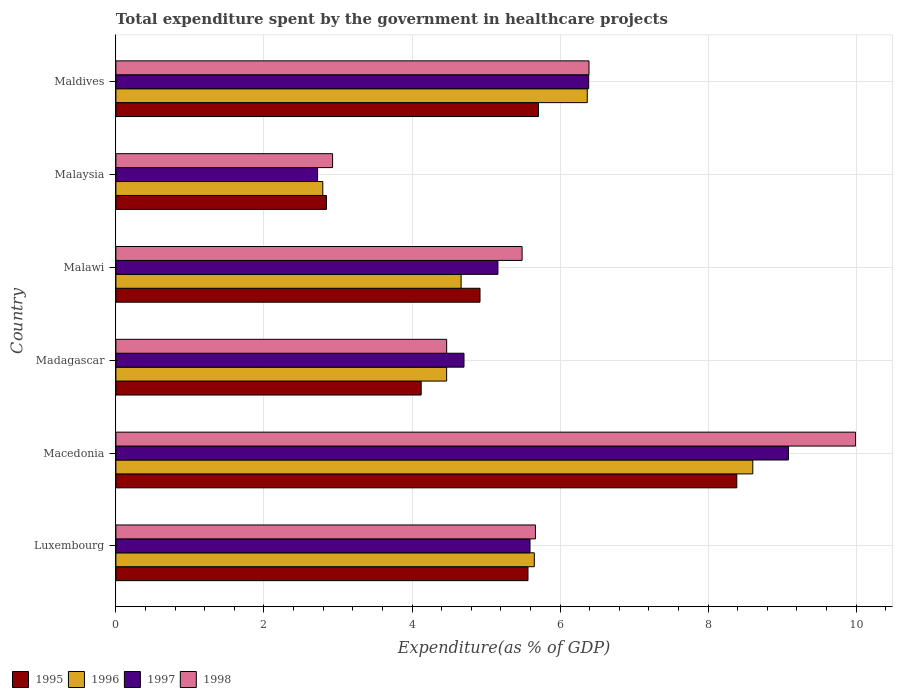Are the number of bars on each tick of the Y-axis equal?
Offer a very short reply. Yes. How many bars are there on the 3rd tick from the top?
Provide a succinct answer. 4. What is the label of the 2nd group of bars from the top?
Give a very brief answer. Malaysia. What is the total expenditure spent by the government in healthcare projects in 1998 in Malaysia?
Your answer should be very brief. 2.93. Across all countries, what is the maximum total expenditure spent by the government in healthcare projects in 1997?
Your answer should be compact. 9.09. Across all countries, what is the minimum total expenditure spent by the government in healthcare projects in 1998?
Keep it short and to the point. 2.93. In which country was the total expenditure spent by the government in healthcare projects in 1998 maximum?
Make the answer very short. Macedonia. In which country was the total expenditure spent by the government in healthcare projects in 1996 minimum?
Keep it short and to the point. Malaysia. What is the total total expenditure spent by the government in healthcare projects in 1997 in the graph?
Make the answer very short. 33.65. What is the difference between the total expenditure spent by the government in healthcare projects in 1996 in Luxembourg and that in Madagascar?
Your answer should be very brief. 1.18. What is the difference between the total expenditure spent by the government in healthcare projects in 1996 in Luxembourg and the total expenditure spent by the government in healthcare projects in 1997 in Macedonia?
Provide a succinct answer. -3.43. What is the average total expenditure spent by the government in healthcare projects in 1996 per country?
Offer a terse response. 5.43. What is the difference between the total expenditure spent by the government in healthcare projects in 1995 and total expenditure spent by the government in healthcare projects in 1997 in Madagascar?
Make the answer very short. -0.58. What is the ratio of the total expenditure spent by the government in healthcare projects in 1998 in Macedonia to that in Madagascar?
Your answer should be compact. 2.24. Is the difference between the total expenditure spent by the government in healthcare projects in 1995 in Macedonia and Malawi greater than the difference between the total expenditure spent by the government in healthcare projects in 1997 in Macedonia and Malawi?
Keep it short and to the point. No. What is the difference between the highest and the second highest total expenditure spent by the government in healthcare projects in 1997?
Provide a succinct answer. 2.7. What is the difference between the highest and the lowest total expenditure spent by the government in healthcare projects in 1996?
Your answer should be compact. 5.81. What does the 1st bar from the top in Maldives represents?
Provide a short and direct response. 1998. What does the 3rd bar from the bottom in Madagascar represents?
Keep it short and to the point. 1997. Are all the bars in the graph horizontal?
Provide a short and direct response. Yes. Are the values on the major ticks of X-axis written in scientific E-notation?
Ensure brevity in your answer.  No. How many legend labels are there?
Give a very brief answer. 4. How are the legend labels stacked?
Keep it short and to the point. Horizontal. What is the title of the graph?
Keep it short and to the point. Total expenditure spent by the government in healthcare projects. Does "1969" appear as one of the legend labels in the graph?
Ensure brevity in your answer.  No. What is the label or title of the X-axis?
Offer a very short reply. Expenditure(as % of GDP). What is the Expenditure(as % of GDP) in 1995 in Luxembourg?
Ensure brevity in your answer.  5.57. What is the Expenditure(as % of GDP) of 1996 in Luxembourg?
Ensure brevity in your answer.  5.65. What is the Expenditure(as % of GDP) of 1997 in Luxembourg?
Ensure brevity in your answer.  5.59. What is the Expenditure(as % of GDP) in 1998 in Luxembourg?
Provide a succinct answer. 5.67. What is the Expenditure(as % of GDP) in 1995 in Macedonia?
Your response must be concise. 8.39. What is the Expenditure(as % of GDP) in 1996 in Macedonia?
Make the answer very short. 8.6. What is the Expenditure(as % of GDP) in 1997 in Macedonia?
Provide a short and direct response. 9.09. What is the Expenditure(as % of GDP) of 1998 in Macedonia?
Your answer should be compact. 9.99. What is the Expenditure(as % of GDP) of 1995 in Madagascar?
Your answer should be compact. 4.12. What is the Expenditure(as % of GDP) of 1996 in Madagascar?
Your response must be concise. 4.47. What is the Expenditure(as % of GDP) of 1997 in Madagascar?
Give a very brief answer. 4.7. What is the Expenditure(as % of GDP) of 1998 in Madagascar?
Make the answer very short. 4.47. What is the Expenditure(as % of GDP) in 1995 in Malawi?
Ensure brevity in your answer.  4.92. What is the Expenditure(as % of GDP) of 1996 in Malawi?
Your answer should be compact. 4.66. What is the Expenditure(as % of GDP) in 1997 in Malawi?
Offer a terse response. 5.16. What is the Expenditure(as % of GDP) of 1998 in Malawi?
Your response must be concise. 5.49. What is the Expenditure(as % of GDP) in 1995 in Malaysia?
Your answer should be compact. 2.84. What is the Expenditure(as % of GDP) in 1996 in Malaysia?
Your response must be concise. 2.8. What is the Expenditure(as % of GDP) of 1997 in Malaysia?
Give a very brief answer. 2.72. What is the Expenditure(as % of GDP) in 1998 in Malaysia?
Provide a succinct answer. 2.93. What is the Expenditure(as % of GDP) of 1995 in Maldives?
Your answer should be compact. 5.71. What is the Expenditure(as % of GDP) in 1996 in Maldives?
Offer a terse response. 6.37. What is the Expenditure(as % of GDP) of 1997 in Maldives?
Provide a short and direct response. 6.39. What is the Expenditure(as % of GDP) of 1998 in Maldives?
Give a very brief answer. 6.39. Across all countries, what is the maximum Expenditure(as % of GDP) of 1995?
Offer a very short reply. 8.39. Across all countries, what is the maximum Expenditure(as % of GDP) in 1996?
Your response must be concise. 8.6. Across all countries, what is the maximum Expenditure(as % of GDP) in 1997?
Ensure brevity in your answer.  9.09. Across all countries, what is the maximum Expenditure(as % of GDP) of 1998?
Keep it short and to the point. 9.99. Across all countries, what is the minimum Expenditure(as % of GDP) in 1995?
Make the answer very short. 2.84. Across all countries, what is the minimum Expenditure(as % of GDP) in 1996?
Provide a short and direct response. 2.8. Across all countries, what is the minimum Expenditure(as % of GDP) of 1997?
Your answer should be compact. 2.72. Across all countries, what is the minimum Expenditure(as % of GDP) of 1998?
Ensure brevity in your answer.  2.93. What is the total Expenditure(as % of GDP) in 1995 in the graph?
Make the answer very short. 31.55. What is the total Expenditure(as % of GDP) of 1996 in the graph?
Provide a short and direct response. 32.55. What is the total Expenditure(as % of GDP) in 1997 in the graph?
Provide a succinct answer. 33.65. What is the total Expenditure(as % of GDP) in 1998 in the graph?
Your response must be concise. 34.93. What is the difference between the Expenditure(as % of GDP) of 1995 in Luxembourg and that in Macedonia?
Your answer should be compact. -2.82. What is the difference between the Expenditure(as % of GDP) of 1996 in Luxembourg and that in Macedonia?
Give a very brief answer. -2.95. What is the difference between the Expenditure(as % of GDP) of 1997 in Luxembourg and that in Macedonia?
Your answer should be very brief. -3.49. What is the difference between the Expenditure(as % of GDP) in 1998 in Luxembourg and that in Macedonia?
Keep it short and to the point. -4.32. What is the difference between the Expenditure(as % of GDP) in 1995 in Luxembourg and that in Madagascar?
Make the answer very short. 1.44. What is the difference between the Expenditure(as % of GDP) in 1996 in Luxembourg and that in Madagascar?
Offer a very short reply. 1.18. What is the difference between the Expenditure(as % of GDP) of 1997 in Luxembourg and that in Madagascar?
Offer a very short reply. 0.89. What is the difference between the Expenditure(as % of GDP) of 1998 in Luxembourg and that in Madagascar?
Give a very brief answer. 1.2. What is the difference between the Expenditure(as % of GDP) in 1995 in Luxembourg and that in Malawi?
Your response must be concise. 0.65. What is the difference between the Expenditure(as % of GDP) in 1996 in Luxembourg and that in Malawi?
Provide a short and direct response. 0.99. What is the difference between the Expenditure(as % of GDP) in 1997 in Luxembourg and that in Malawi?
Your answer should be compact. 0.43. What is the difference between the Expenditure(as % of GDP) of 1998 in Luxembourg and that in Malawi?
Provide a short and direct response. 0.18. What is the difference between the Expenditure(as % of GDP) in 1995 in Luxembourg and that in Malaysia?
Give a very brief answer. 2.72. What is the difference between the Expenditure(as % of GDP) in 1996 in Luxembourg and that in Malaysia?
Provide a succinct answer. 2.86. What is the difference between the Expenditure(as % of GDP) of 1997 in Luxembourg and that in Malaysia?
Your answer should be compact. 2.87. What is the difference between the Expenditure(as % of GDP) of 1998 in Luxembourg and that in Malaysia?
Offer a terse response. 2.74. What is the difference between the Expenditure(as % of GDP) in 1995 in Luxembourg and that in Maldives?
Your answer should be compact. -0.14. What is the difference between the Expenditure(as % of GDP) of 1996 in Luxembourg and that in Maldives?
Make the answer very short. -0.72. What is the difference between the Expenditure(as % of GDP) in 1997 in Luxembourg and that in Maldives?
Offer a terse response. -0.79. What is the difference between the Expenditure(as % of GDP) in 1998 in Luxembourg and that in Maldives?
Offer a terse response. -0.72. What is the difference between the Expenditure(as % of GDP) of 1995 in Macedonia and that in Madagascar?
Offer a very short reply. 4.26. What is the difference between the Expenditure(as % of GDP) of 1996 in Macedonia and that in Madagascar?
Offer a terse response. 4.14. What is the difference between the Expenditure(as % of GDP) of 1997 in Macedonia and that in Madagascar?
Your answer should be compact. 4.38. What is the difference between the Expenditure(as % of GDP) of 1998 in Macedonia and that in Madagascar?
Your response must be concise. 5.52. What is the difference between the Expenditure(as % of GDP) in 1995 in Macedonia and that in Malawi?
Make the answer very short. 3.47. What is the difference between the Expenditure(as % of GDP) of 1996 in Macedonia and that in Malawi?
Your response must be concise. 3.94. What is the difference between the Expenditure(as % of GDP) of 1997 in Macedonia and that in Malawi?
Provide a succinct answer. 3.92. What is the difference between the Expenditure(as % of GDP) of 1998 in Macedonia and that in Malawi?
Ensure brevity in your answer.  4.5. What is the difference between the Expenditure(as % of GDP) in 1995 in Macedonia and that in Malaysia?
Give a very brief answer. 5.54. What is the difference between the Expenditure(as % of GDP) in 1996 in Macedonia and that in Malaysia?
Provide a short and direct response. 5.81. What is the difference between the Expenditure(as % of GDP) of 1997 in Macedonia and that in Malaysia?
Your answer should be compact. 6.36. What is the difference between the Expenditure(as % of GDP) of 1998 in Macedonia and that in Malaysia?
Make the answer very short. 7.06. What is the difference between the Expenditure(as % of GDP) in 1995 in Macedonia and that in Maldives?
Offer a terse response. 2.68. What is the difference between the Expenditure(as % of GDP) in 1996 in Macedonia and that in Maldives?
Your answer should be compact. 2.24. What is the difference between the Expenditure(as % of GDP) in 1997 in Macedonia and that in Maldives?
Offer a terse response. 2.7. What is the difference between the Expenditure(as % of GDP) in 1998 in Macedonia and that in Maldives?
Keep it short and to the point. 3.6. What is the difference between the Expenditure(as % of GDP) of 1995 in Madagascar and that in Malawi?
Offer a terse response. -0.79. What is the difference between the Expenditure(as % of GDP) in 1996 in Madagascar and that in Malawi?
Provide a succinct answer. -0.2. What is the difference between the Expenditure(as % of GDP) of 1997 in Madagascar and that in Malawi?
Keep it short and to the point. -0.46. What is the difference between the Expenditure(as % of GDP) in 1998 in Madagascar and that in Malawi?
Offer a terse response. -1.02. What is the difference between the Expenditure(as % of GDP) in 1995 in Madagascar and that in Malaysia?
Provide a short and direct response. 1.28. What is the difference between the Expenditure(as % of GDP) in 1996 in Madagascar and that in Malaysia?
Ensure brevity in your answer.  1.67. What is the difference between the Expenditure(as % of GDP) of 1997 in Madagascar and that in Malaysia?
Offer a terse response. 1.98. What is the difference between the Expenditure(as % of GDP) in 1998 in Madagascar and that in Malaysia?
Offer a very short reply. 1.54. What is the difference between the Expenditure(as % of GDP) in 1995 in Madagascar and that in Maldives?
Make the answer very short. -1.58. What is the difference between the Expenditure(as % of GDP) in 1996 in Madagascar and that in Maldives?
Ensure brevity in your answer.  -1.9. What is the difference between the Expenditure(as % of GDP) in 1997 in Madagascar and that in Maldives?
Your answer should be compact. -1.68. What is the difference between the Expenditure(as % of GDP) in 1998 in Madagascar and that in Maldives?
Your response must be concise. -1.92. What is the difference between the Expenditure(as % of GDP) of 1995 in Malawi and that in Malaysia?
Keep it short and to the point. 2.07. What is the difference between the Expenditure(as % of GDP) of 1996 in Malawi and that in Malaysia?
Keep it short and to the point. 1.87. What is the difference between the Expenditure(as % of GDP) of 1997 in Malawi and that in Malaysia?
Provide a short and direct response. 2.44. What is the difference between the Expenditure(as % of GDP) of 1998 in Malawi and that in Malaysia?
Offer a very short reply. 2.56. What is the difference between the Expenditure(as % of GDP) of 1995 in Malawi and that in Maldives?
Your response must be concise. -0.79. What is the difference between the Expenditure(as % of GDP) in 1996 in Malawi and that in Maldives?
Keep it short and to the point. -1.7. What is the difference between the Expenditure(as % of GDP) in 1997 in Malawi and that in Maldives?
Offer a very short reply. -1.23. What is the difference between the Expenditure(as % of GDP) in 1998 in Malawi and that in Maldives?
Ensure brevity in your answer.  -0.9. What is the difference between the Expenditure(as % of GDP) of 1995 in Malaysia and that in Maldives?
Your answer should be very brief. -2.86. What is the difference between the Expenditure(as % of GDP) of 1996 in Malaysia and that in Maldives?
Offer a very short reply. -3.57. What is the difference between the Expenditure(as % of GDP) of 1997 in Malaysia and that in Maldives?
Keep it short and to the point. -3.66. What is the difference between the Expenditure(as % of GDP) in 1998 in Malaysia and that in Maldives?
Provide a short and direct response. -3.46. What is the difference between the Expenditure(as % of GDP) in 1995 in Luxembourg and the Expenditure(as % of GDP) in 1996 in Macedonia?
Your response must be concise. -3.04. What is the difference between the Expenditure(as % of GDP) in 1995 in Luxembourg and the Expenditure(as % of GDP) in 1997 in Macedonia?
Ensure brevity in your answer.  -3.52. What is the difference between the Expenditure(as % of GDP) of 1995 in Luxembourg and the Expenditure(as % of GDP) of 1998 in Macedonia?
Your response must be concise. -4.42. What is the difference between the Expenditure(as % of GDP) of 1996 in Luxembourg and the Expenditure(as % of GDP) of 1997 in Macedonia?
Provide a succinct answer. -3.43. What is the difference between the Expenditure(as % of GDP) of 1996 in Luxembourg and the Expenditure(as % of GDP) of 1998 in Macedonia?
Your answer should be compact. -4.34. What is the difference between the Expenditure(as % of GDP) in 1997 in Luxembourg and the Expenditure(as % of GDP) in 1998 in Macedonia?
Provide a succinct answer. -4.4. What is the difference between the Expenditure(as % of GDP) of 1995 in Luxembourg and the Expenditure(as % of GDP) of 1996 in Madagascar?
Ensure brevity in your answer.  1.1. What is the difference between the Expenditure(as % of GDP) of 1995 in Luxembourg and the Expenditure(as % of GDP) of 1997 in Madagascar?
Your response must be concise. 0.86. What is the difference between the Expenditure(as % of GDP) of 1995 in Luxembourg and the Expenditure(as % of GDP) of 1998 in Madagascar?
Give a very brief answer. 1.1. What is the difference between the Expenditure(as % of GDP) in 1996 in Luxembourg and the Expenditure(as % of GDP) in 1997 in Madagascar?
Keep it short and to the point. 0.95. What is the difference between the Expenditure(as % of GDP) of 1996 in Luxembourg and the Expenditure(as % of GDP) of 1998 in Madagascar?
Your answer should be compact. 1.18. What is the difference between the Expenditure(as % of GDP) of 1997 in Luxembourg and the Expenditure(as % of GDP) of 1998 in Madagascar?
Make the answer very short. 1.13. What is the difference between the Expenditure(as % of GDP) in 1995 in Luxembourg and the Expenditure(as % of GDP) in 1996 in Malawi?
Provide a succinct answer. 0.9. What is the difference between the Expenditure(as % of GDP) of 1995 in Luxembourg and the Expenditure(as % of GDP) of 1997 in Malawi?
Ensure brevity in your answer.  0.41. What is the difference between the Expenditure(as % of GDP) of 1995 in Luxembourg and the Expenditure(as % of GDP) of 1998 in Malawi?
Give a very brief answer. 0.08. What is the difference between the Expenditure(as % of GDP) of 1996 in Luxembourg and the Expenditure(as % of GDP) of 1997 in Malawi?
Ensure brevity in your answer.  0.49. What is the difference between the Expenditure(as % of GDP) of 1996 in Luxembourg and the Expenditure(as % of GDP) of 1998 in Malawi?
Give a very brief answer. 0.17. What is the difference between the Expenditure(as % of GDP) in 1997 in Luxembourg and the Expenditure(as % of GDP) in 1998 in Malawi?
Offer a terse response. 0.11. What is the difference between the Expenditure(as % of GDP) of 1995 in Luxembourg and the Expenditure(as % of GDP) of 1996 in Malaysia?
Provide a short and direct response. 2.77. What is the difference between the Expenditure(as % of GDP) in 1995 in Luxembourg and the Expenditure(as % of GDP) in 1997 in Malaysia?
Provide a short and direct response. 2.84. What is the difference between the Expenditure(as % of GDP) in 1995 in Luxembourg and the Expenditure(as % of GDP) in 1998 in Malaysia?
Provide a short and direct response. 2.64. What is the difference between the Expenditure(as % of GDP) of 1996 in Luxembourg and the Expenditure(as % of GDP) of 1997 in Malaysia?
Give a very brief answer. 2.93. What is the difference between the Expenditure(as % of GDP) of 1996 in Luxembourg and the Expenditure(as % of GDP) of 1998 in Malaysia?
Offer a very short reply. 2.73. What is the difference between the Expenditure(as % of GDP) in 1997 in Luxembourg and the Expenditure(as % of GDP) in 1998 in Malaysia?
Your answer should be very brief. 2.67. What is the difference between the Expenditure(as % of GDP) of 1995 in Luxembourg and the Expenditure(as % of GDP) of 1996 in Maldives?
Give a very brief answer. -0.8. What is the difference between the Expenditure(as % of GDP) of 1995 in Luxembourg and the Expenditure(as % of GDP) of 1997 in Maldives?
Your response must be concise. -0.82. What is the difference between the Expenditure(as % of GDP) in 1995 in Luxembourg and the Expenditure(as % of GDP) in 1998 in Maldives?
Provide a short and direct response. -0.82. What is the difference between the Expenditure(as % of GDP) of 1996 in Luxembourg and the Expenditure(as % of GDP) of 1997 in Maldives?
Ensure brevity in your answer.  -0.73. What is the difference between the Expenditure(as % of GDP) in 1996 in Luxembourg and the Expenditure(as % of GDP) in 1998 in Maldives?
Ensure brevity in your answer.  -0.74. What is the difference between the Expenditure(as % of GDP) in 1997 in Luxembourg and the Expenditure(as % of GDP) in 1998 in Maldives?
Provide a succinct answer. -0.8. What is the difference between the Expenditure(as % of GDP) of 1995 in Macedonia and the Expenditure(as % of GDP) of 1996 in Madagascar?
Your response must be concise. 3.92. What is the difference between the Expenditure(as % of GDP) in 1995 in Macedonia and the Expenditure(as % of GDP) in 1997 in Madagascar?
Your response must be concise. 3.69. What is the difference between the Expenditure(as % of GDP) of 1995 in Macedonia and the Expenditure(as % of GDP) of 1998 in Madagascar?
Provide a succinct answer. 3.92. What is the difference between the Expenditure(as % of GDP) of 1996 in Macedonia and the Expenditure(as % of GDP) of 1997 in Madagascar?
Make the answer very short. 3.9. What is the difference between the Expenditure(as % of GDP) of 1996 in Macedonia and the Expenditure(as % of GDP) of 1998 in Madagascar?
Your answer should be very brief. 4.14. What is the difference between the Expenditure(as % of GDP) of 1997 in Macedonia and the Expenditure(as % of GDP) of 1998 in Madagascar?
Give a very brief answer. 4.62. What is the difference between the Expenditure(as % of GDP) of 1995 in Macedonia and the Expenditure(as % of GDP) of 1996 in Malawi?
Offer a terse response. 3.72. What is the difference between the Expenditure(as % of GDP) in 1995 in Macedonia and the Expenditure(as % of GDP) in 1997 in Malawi?
Provide a short and direct response. 3.23. What is the difference between the Expenditure(as % of GDP) of 1995 in Macedonia and the Expenditure(as % of GDP) of 1998 in Malawi?
Provide a short and direct response. 2.9. What is the difference between the Expenditure(as % of GDP) of 1996 in Macedonia and the Expenditure(as % of GDP) of 1997 in Malawi?
Offer a very short reply. 3.44. What is the difference between the Expenditure(as % of GDP) of 1996 in Macedonia and the Expenditure(as % of GDP) of 1998 in Malawi?
Ensure brevity in your answer.  3.12. What is the difference between the Expenditure(as % of GDP) in 1997 in Macedonia and the Expenditure(as % of GDP) in 1998 in Malawi?
Keep it short and to the point. 3.6. What is the difference between the Expenditure(as % of GDP) in 1995 in Macedonia and the Expenditure(as % of GDP) in 1996 in Malaysia?
Your answer should be compact. 5.59. What is the difference between the Expenditure(as % of GDP) in 1995 in Macedonia and the Expenditure(as % of GDP) in 1997 in Malaysia?
Make the answer very short. 5.66. What is the difference between the Expenditure(as % of GDP) of 1995 in Macedonia and the Expenditure(as % of GDP) of 1998 in Malaysia?
Provide a short and direct response. 5.46. What is the difference between the Expenditure(as % of GDP) in 1996 in Macedonia and the Expenditure(as % of GDP) in 1997 in Malaysia?
Your response must be concise. 5.88. What is the difference between the Expenditure(as % of GDP) of 1996 in Macedonia and the Expenditure(as % of GDP) of 1998 in Malaysia?
Your answer should be very brief. 5.68. What is the difference between the Expenditure(as % of GDP) in 1997 in Macedonia and the Expenditure(as % of GDP) in 1998 in Malaysia?
Give a very brief answer. 6.16. What is the difference between the Expenditure(as % of GDP) in 1995 in Macedonia and the Expenditure(as % of GDP) in 1996 in Maldives?
Provide a succinct answer. 2.02. What is the difference between the Expenditure(as % of GDP) in 1995 in Macedonia and the Expenditure(as % of GDP) in 1997 in Maldives?
Give a very brief answer. 2. What is the difference between the Expenditure(as % of GDP) in 1995 in Macedonia and the Expenditure(as % of GDP) in 1998 in Maldives?
Your answer should be compact. 2. What is the difference between the Expenditure(as % of GDP) of 1996 in Macedonia and the Expenditure(as % of GDP) of 1997 in Maldives?
Your response must be concise. 2.22. What is the difference between the Expenditure(as % of GDP) of 1996 in Macedonia and the Expenditure(as % of GDP) of 1998 in Maldives?
Offer a very short reply. 2.21. What is the difference between the Expenditure(as % of GDP) of 1997 in Macedonia and the Expenditure(as % of GDP) of 1998 in Maldives?
Offer a terse response. 2.69. What is the difference between the Expenditure(as % of GDP) in 1995 in Madagascar and the Expenditure(as % of GDP) in 1996 in Malawi?
Ensure brevity in your answer.  -0.54. What is the difference between the Expenditure(as % of GDP) in 1995 in Madagascar and the Expenditure(as % of GDP) in 1997 in Malawi?
Ensure brevity in your answer.  -1.04. What is the difference between the Expenditure(as % of GDP) of 1995 in Madagascar and the Expenditure(as % of GDP) of 1998 in Malawi?
Give a very brief answer. -1.36. What is the difference between the Expenditure(as % of GDP) of 1996 in Madagascar and the Expenditure(as % of GDP) of 1997 in Malawi?
Give a very brief answer. -0.69. What is the difference between the Expenditure(as % of GDP) in 1996 in Madagascar and the Expenditure(as % of GDP) in 1998 in Malawi?
Provide a short and direct response. -1.02. What is the difference between the Expenditure(as % of GDP) in 1997 in Madagascar and the Expenditure(as % of GDP) in 1998 in Malawi?
Keep it short and to the point. -0.78. What is the difference between the Expenditure(as % of GDP) of 1995 in Madagascar and the Expenditure(as % of GDP) of 1996 in Malaysia?
Offer a very short reply. 1.33. What is the difference between the Expenditure(as % of GDP) of 1995 in Madagascar and the Expenditure(as % of GDP) of 1997 in Malaysia?
Ensure brevity in your answer.  1.4. What is the difference between the Expenditure(as % of GDP) in 1995 in Madagascar and the Expenditure(as % of GDP) in 1998 in Malaysia?
Give a very brief answer. 1.2. What is the difference between the Expenditure(as % of GDP) of 1996 in Madagascar and the Expenditure(as % of GDP) of 1997 in Malaysia?
Ensure brevity in your answer.  1.74. What is the difference between the Expenditure(as % of GDP) in 1996 in Madagascar and the Expenditure(as % of GDP) in 1998 in Malaysia?
Make the answer very short. 1.54. What is the difference between the Expenditure(as % of GDP) of 1997 in Madagascar and the Expenditure(as % of GDP) of 1998 in Malaysia?
Keep it short and to the point. 1.78. What is the difference between the Expenditure(as % of GDP) of 1995 in Madagascar and the Expenditure(as % of GDP) of 1996 in Maldives?
Your answer should be compact. -2.24. What is the difference between the Expenditure(as % of GDP) in 1995 in Madagascar and the Expenditure(as % of GDP) in 1997 in Maldives?
Give a very brief answer. -2.26. What is the difference between the Expenditure(as % of GDP) of 1995 in Madagascar and the Expenditure(as % of GDP) of 1998 in Maldives?
Provide a succinct answer. -2.27. What is the difference between the Expenditure(as % of GDP) of 1996 in Madagascar and the Expenditure(as % of GDP) of 1997 in Maldives?
Keep it short and to the point. -1.92. What is the difference between the Expenditure(as % of GDP) of 1996 in Madagascar and the Expenditure(as % of GDP) of 1998 in Maldives?
Your response must be concise. -1.92. What is the difference between the Expenditure(as % of GDP) in 1997 in Madagascar and the Expenditure(as % of GDP) in 1998 in Maldives?
Offer a terse response. -1.69. What is the difference between the Expenditure(as % of GDP) of 1995 in Malawi and the Expenditure(as % of GDP) of 1996 in Malaysia?
Your response must be concise. 2.12. What is the difference between the Expenditure(as % of GDP) in 1995 in Malawi and the Expenditure(as % of GDP) in 1997 in Malaysia?
Your answer should be very brief. 2.19. What is the difference between the Expenditure(as % of GDP) of 1995 in Malawi and the Expenditure(as % of GDP) of 1998 in Malaysia?
Give a very brief answer. 1.99. What is the difference between the Expenditure(as % of GDP) in 1996 in Malawi and the Expenditure(as % of GDP) in 1997 in Malaysia?
Give a very brief answer. 1.94. What is the difference between the Expenditure(as % of GDP) of 1996 in Malawi and the Expenditure(as % of GDP) of 1998 in Malaysia?
Offer a very short reply. 1.74. What is the difference between the Expenditure(as % of GDP) of 1997 in Malawi and the Expenditure(as % of GDP) of 1998 in Malaysia?
Offer a terse response. 2.23. What is the difference between the Expenditure(as % of GDP) of 1995 in Malawi and the Expenditure(as % of GDP) of 1996 in Maldives?
Keep it short and to the point. -1.45. What is the difference between the Expenditure(as % of GDP) of 1995 in Malawi and the Expenditure(as % of GDP) of 1997 in Maldives?
Offer a very short reply. -1.47. What is the difference between the Expenditure(as % of GDP) in 1995 in Malawi and the Expenditure(as % of GDP) in 1998 in Maldives?
Your response must be concise. -1.47. What is the difference between the Expenditure(as % of GDP) of 1996 in Malawi and the Expenditure(as % of GDP) of 1997 in Maldives?
Make the answer very short. -1.72. What is the difference between the Expenditure(as % of GDP) of 1996 in Malawi and the Expenditure(as % of GDP) of 1998 in Maldives?
Offer a very short reply. -1.73. What is the difference between the Expenditure(as % of GDP) of 1997 in Malawi and the Expenditure(as % of GDP) of 1998 in Maldives?
Ensure brevity in your answer.  -1.23. What is the difference between the Expenditure(as % of GDP) in 1995 in Malaysia and the Expenditure(as % of GDP) in 1996 in Maldives?
Offer a very short reply. -3.52. What is the difference between the Expenditure(as % of GDP) in 1995 in Malaysia and the Expenditure(as % of GDP) in 1997 in Maldives?
Your response must be concise. -3.54. What is the difference between the Expenditure(as % of GDP) of 1995 in Malaysia and the Expenditure(as % of GDP) of 1998 in Maldives?
Make the answer very short. -3.55. What is the difference between the Expenditure(as % of GDP) in 1996 in Malaysia and the Expenditure(as % of GDP) in 1997 in Maldives?
Offer a very short reply. -3.59. What is the difference between the Expenditure(as % of GDP) in 1996 in Malaysia and the Expenditure(as % of GDP) in 1998 in Maldives?
Keep it short and to the point. -3.6. What is the difference between the Expenditure(as % of GDP) of 1997 in Malaysia and the Expenditure(as % of GDP) of 1998 in Maldives?
Your answer should be very brief. -3.67. What is the average Expenditure(as % of GDP) in 1995 per country?
Give a very brief answer. 5.26. What is the average Expenditure(as % of GDP) in 1996 per country?
Provide a succinct answer. 5.42. What is the average Expenditure(as % of GDP) in 1997 per country?
Your answer should be very brief. 5.61. What is the average Expenditure(as % of GDP) in 1998 per country?
Provide a succinct answer. 5.82. What is the difference between the Expenditure(as % of GDP) in 1995 and Expenditure(as % of GDP) in 1996 in Luxembourg?
Provide a succinct answer. -0.09. What is the difference between the Expenditure(as % of GDP) in 1995 and Expenditure(as % of GDP) in 1997 in Luxembourg?
Keep it short and to the point. -0.03. What is the difference between the Expenditure(as % of GDP) of 1995 and Expenditure(as % of GDP) of 1998 in Luxembourg?
Offer a terse response. -0.1. What is the difference between the Expenditure(as % of GDP) in 1996 and Expenditure(as % of GDP) in 1997 in Luxembourg?
Offer a very short reply. 0.06. What is the difference between the Expenditure(as % of GDP) of 1996 and Expenditure(as % of GDP) of 1998 in Luxembourg?
Your answer should be compact. -0.02. What is the difference between the Expenditure(as % of GDP) in 1997 and Expenditure(as % of GDP) in 1998 in Luxembourg?
Give a very brief answer. -0.07. What is the difference between the Expenditure(as % of GDP) of 1995 and Expenditure(as % of GDP) of 1996 in Macedonia?
Keep it short and to the point. -0.22. What is the difference between the Expenditure(as % of GDP) of 1995 and Expenditure(as % of GDP) of 1997 in Macedonia?
Give a very brief answer. -0.7. What is the difference between the Expenditure(as % of GDP) in 1995 and Expenditure(as % of GDP) in 1998 in Macedonia?
Provide a succinct answer. -1.6. What is the difference between the Expenditure(as % of GDP) in 1996 and Expenditure(as % of GDP) in 1997 in Macedonia?
Your answer should be compact. -0.48. What is the difference between the Expenditure(as % of GDP) of 1996 and Expenditure(as % of GDP) of 1998 in Macedonia?
Your response must be concise. -1.39. What is the difference between the Expenditure(as % of GDP) in 1997 and Expenditure(as % of GDP) in 1998 in Macedonia?
Your response must be concise. -0.91. What is the difference between the Expenditure(as % of GDP) of 1995 and Expenditure(as % of GDP) of 1996 in Madagascar?
Your response must be concise. -0.34. What is the difference between the Expenditure(as % of GDP) of 1995 and Expenditure(as % of GDP) of 1997 in Madagascar?
Make the answer very short. -0.58. What is the difference between the Expenditure(as % of GDP) of 1995 and Expenditure(as % of GDP) of 1998 in Madagascar?
Make the answer very short. -0.34. What is the difference between the Expenditure(as % of GDP) of 1996 and Expenditure(as % of GDP) of 1997 in Madagascar?
Your response must be concise. -0.23. What is the difference between the Expenditure(as % of GDP) of 1996 and Expenditure(as % of GDP) of 1998 in Madagascar?
Provide a succinct answer. -0. What is the difference between the Expenditure(as % of GDP) in 1997 and Expenditure(as % of GDP) in 1998 in Madagascar?
Ensure brevity in your answer.  0.23. What is the difference between the Expenditure(as % of GDP) in 1995 and Expenditure(as % of GDP) in 1996 in Malawi?
Provide a short and direct response. 0.26. What is the difference between the Expenditure(as % of GDP) in 1995 and Expenditure(as % of GDP) in 1997 in Malawi?
Provide a short and direct response. -0.24. What is the difference between the Expenditure(as % of GDP) in 1995 and Expenditure(as % of GDP) in 1998 in Malawi?
Give a very brief answer. -0.57. What is the difference between the Expenditure(as % of GDP) in 1996 and Expenditure(as % of GDP) in 1997 in Malawi?
Provide a short and direct response. -0.5. What is the difference between the Expenditure(as % of GDP) in 1996 and Expenditure(as % of GDP) in 1998 in Malawi?
Offer a very short reply. -0.82. What is the difference between the Expenditure(as % of GDP) of 1997 and Expenditure(as % of GDP) of 1998 in Malawi?
Provide a short and direct response. -0.33. What is the difference between the Expenditure(as % of GDP) in 1995 and Expenditure(as % of GDP) in 1996 in Malaysia?
Your answer should be compact. 0.05. What is the difference between the Expenditure(as % of GDP) in 1995 and Expenditure(as % of GDP) in 1997 in Malaysia?
Make the answer very short. 0.12. What is the difference between the Expenditure(as % of GDP) in 1995 and Expenditure(as % of GDP) in 1998 in Malaysia?
Offer a very short reply. -0.08. What is the difference between the Expenditure(as % of GDP) of 1996 and Expenditure(as % of GDP) of 1997 in Malaysia?
Your answer should be compact. 0.07. What is the difference between the Expenditure(as % of GDP) in 1996 and Expenditure(as % of GDP) in 1998 in Malaysia?
Offer a very short reply. -0.13. What is the difference between the Expenditure(as % of GDP) of 1997 and Expenditure(as % of GDP) of 1998 in Malaysia?
Give a very brief answer. -0.2. What is the difference between the Expenditure(as % of GDP) of 1995 and Expenditure(as % of GDP) of 1996 in Maldives?
Your answer should be very brief. -0.66. What is the difference between the Expenditure(as % of GDP) of 1995 and Expenditure(as % of GDP) of 1997 in Maldives?
Make the answer very short. -0.68. What is the difference between the Expenditure(as % of GDP) in 1995 and Expenditure(as % of GDP) in 1998 in Maldives?
Keep it short and to the point. -0.68. What is the difference between the Expenditure(as % of GDP) of 1996 and Expenditure(as % of GDP) of 1997 in Maldives?
Your answer should be compact. -0.02. What is the difference between the Expenditure(as % of GDP) of 1996 and Expenditure(as % of GDP) of 1998 in Maldives?
Give a very brief answer. -0.02. What is the difference between the Expenditure(as % of GDP) in 1997 and Expenditure(as % of GDP) in 1998 in Maldives?
Offer a very short reply. -0. What is the ratio of the Expenditure(as % of GDP) in 1995 in Luxembourg to that in Macedonia?
Your response must be concise. 0.66. What is the ratio of the Expenditure(as % of GDP) of 1996 in Luxembourg to that in Macedonia?
Make the answer very short. 0.66. What is the ratio of the Expenditure(as % of GDP) in 1997 in Luxembourg to that in Macedonia?
Offer a very short reply. 0.62. What is the ratio of the Expenditure(as % of GDP) in 1998 in Luxembourg to that in Macedonia?
Provide a succinct answer. 0.57. What is the ratio of the Expenditure(as % of GDP) in 1995 in Luxembourg to that in Madagascar?
Make the answer very short. 1.35. What is the ratio of the Expenditure(as % of GDP) in 1996 in Luxembourg to that in Madagascar?
Your answer should be very brief. 1.26. What is the ratio of the Expenditure(as % of GDP) of 1997 in Luxembourg to that in Madagascar?
Provide a succinct answer. 1.19. What is the ratio of the Expenditure(as % of GDP) of 1998 in Luxembourg to that in Madagascar?
Offer a very short reply. 1.27. What is the ratio of the Expenditure(as % of GDP) of 1995 in Luxembourg to that in Malawi?
Your answer should be compact. 1.13. What is the ratio of the Expenditure(as % of GDP) of 1996 in Luxembourg to that in Malawi?
Your answer should be compact. 1.21. What is the ratio of the Expenditure(as % of GDP) of 1997 in Luxembourg to that in Malawi?
Offer a very short reply. 1.08. What is the ratio of the Expenditure(as % of GDP) in 1998 in Luxembourg to that in Malawi?
Provide a short and direct response. 1.03. What is the ratio of the Expenditure(as % of GDP) in 1995 in Luxembourg to that in Malaysia?
Give a very brief answer. 1.96. What is the ratio of the Expenditure(as % of GDP) of 1996 in Luxembourg to that in Malaysia?
Your response must be concise. 2.02. What is the ratio of the Expenditure(as % of GDP) of 1997 in Luxembourg to that in Malaysia?
Provide a succinct answer. 2.05. What is the ratio of the Expenditure(as % of GDP) of 1998 in Luxembourg to that in Malaysia?
Provide a short and direct response. 1.94. What is the ratio of the Expenditure(as % of GDP) in 1995 in Luxembourg to that in Maldives?
Your response must be concise. 0.98. What is the ratio of the Expenditure(as % of GDP) of 1996 in Luxembourg to that in Maldives?
Make the answer very short. 0.89. What is the ratio of the Expenditure(as % of GDP) of 1997 in Luxembourg to that in Maldives?
Your answer should be very brief. 0.88. What is the ratio of the Expenditure(as % of GDP) in 1998 in Luxembourg to that in Maldives?
Your answer should be very brief. 0.89. What is the ratio of the Expenditure(as % of GDP) of 1995 in Macedonia to that in Madagascar?
Offer a terse response. 2.03. What is the ratio of the Expenditure(as % of GDP) of 1996 in Macedonia to that in Madagascar?
Provide a succinct answer. 1.93. What is the ratio of the Expenditure(as % of GDP) of 1997 in Macedonia to that in Madagascar?
Keep it short and to the point. 1.93. What is the ratio of the Expenditure(as % of GDP) in 1998 in Macedonia to that in Madagascar?
Your response must be concise. 2.24. What is the ratio of the Expenditure(as % of GDP) of 1995 in Macedonia to that in Malawi?
Provide a succinct answer. 1.71. What is the ratio of the Expenditure(as % of GDP) in 1996 in Macedonia to that in Malawi?
Your answer should be compact. 1.84. What is the ratio of the Expenditure(as % of GDP) of 1997 in Macedonia to that in Malawi?
Provide a short and direct response. 1.76. What is the ratio of the Expenditure(as % of GDP) in 1998 in Macedonia to that in Malawi?
Your answer should be very brief. 1.82. What is the ratio of the Expenditure(as % of GDP) of 1995 in Macedonia to that in Malaysia?
Ensure brevity in your answer.  2.95. What is the ratio of the Expenditure(as % of GDP) of 1996 in Macedonia to that in Malaysia?
Offer a terse response. 3.08. What is the ratio of the Expenditure(as % of GDP) of 1997 in Macedonia to that in Malaysia?
Offer a very short reply. 3.33. What is the ratio of the Expenditure(as % of GDP) of 1998 in Macedonia to that in Malaysia?
Offer a terse response. 3.41. What is the ratio of the Expenditure(as % of GDP) in 1995 in Macedonia to that in Maldives?
Offer a very short reply. 1.47. What is the ratio of the Expenditure(as % of GDP) of 1996 in Macedonia to that in Maldives?
Provide a short and direct response. 1.35. What is the ratio of the Expenditure(as % of GDP) of 1997 in Macedonia to that in Maldives?
Give a very brief answer. 1.42. What is the ratio of the Expenditure(as % of GDP) of 1998 in Macedonia to that in Maldives?
Make the answer very short. 1.56. What is the ratio of the Expenditure(as % of GDP) in 1995 in Madagascar to that in Malawi?
Offer a terse response. 0.84. What is the ratio of the Expenditure(as % of GDP) in 1996 in Madagascar to that in Malawi?
Provide a short and direct response. 0.96. What is the ratio of the Expenditure(as % of GDP) of 1997 in Madagascar to that in Malawi?
Give a very brief answer. 0.91. What is the ratio of the Expenditure(as % of GDP) in 1998 in Madagascar to that in Malawi?
Offer a very short reply. 0.81. What is the ratio of the Expenditure(as % of GDP) of 1995 in Madagascar to that in Malaysia?
Provide a succinct answer. 1.45. What is the ratio of the Expenditure(as % of GDP) of 1996 in Madagascar to that in Malaysia?
Keep it short and to the point. 1.6. What is the ratio of the Expenditure(as % of GDP) of 1997 in Madagascar to that in Malaysia?
Keep it short and to the point. 1.73. What is the ratio of the Expenditure(as % of GDP) of 1998 in Madagascar to that in Malaysia?
Ensure brevity in your answer.  1.53. What is the ratio of the Expenditure(as % of GDP) in 1995 in Madagascar to that in Maldives?
Ensure brevity in your answer.  0.72. What is the ratio of the Expenditure(as % of GDP) of 1996 in Madagascar to that in Maldives?
Your answer should be very brief. 0.7. What is the ratio of the Expenditure(as % of GDP) of 1997 in Madagascar to that in Maldives?
Keep it short and to the point. 0.74. What is the ratio of the Expenditure(as % of GDP) of 1998 in Madagascar to that in Maldives?
Your answer should be very brief. 0.7. What is the ratio of the Expenditure(as % of GDP) of 1995 in Malawi to that in Malaysia?
Your answer should be very brief. 1.73. What is the ratio of the Expenditure(as % of GDP) of 1996 in Malawi to that in Malaysia?
Your response must be concise. 1.67. What is the ratio of the Expenditure(as % of GDP) of 1997 in Malawi to that in Malaysia?
Your answer should be compact. 1.89. What is the ratio of the Expenditure(as % of GDP) in 1998 in Malawi to that in Malaysia?
Give a very brief answer. 1.87. What is the ratio of the Expenditure(as % of GDP) in 1995 in Malawi to that in Maldives?
Your response must be concise. 0.86. What is the ratio of the Expenditure(as % of GDP) in 1996 in Malawi to that in Maldives?
Make the answer very short. 0.73. What is the ratio of the Expenditure(as % of GDP) in 1997 in Malawi to that in Maldives?
Offer a terse response. 0.81. What is the ratio of the Expenditure(as % of GDP) in 1998 in Malawi to that in Maldives?
Your answer should be compact. 0.86. What is the ratio of the Expenditure(as % of GDP) in 1995 in Malaysia to that in Maldives?
Provide a short and direct response. 0.5. What is the ratio of the Expenditure(as % of GDP) in 1996 in Malaysia to that in Maldives?
Your response must be concise. 0.44. What is the ratio of the Expenditure(as % of GDP) in 1997 in Malaysia to that in Maldives?
Provide a succinct answer. 0.43. What is the ratio of the Expenditure(as % of GDP) of 1998 in Malaysia to that in Maldives?
Your answer should be compact. 0.46. What is the difference between the highest and the second highest Expenditure(as % of GDP) of 1995?
Keep it short and to the point. 2.68. What is the difference between the highest and the second highest Expenditure(as % of GDP) of 1996?
Ensure brevity in your answer.  2.24. What is the difference between the highest and the second highest Expenditure(as % of GDP) of 1997?
Keep it short and to the point. 2.7. What is the difference between the highest and the second highest Expenditure(as % of GDP) of 1998?
Your answer should be very brief. 3.6. What is the difference between the highest and the lowest Expenditure(as % of GDP) in 1995?
Make the answer very short. 5.54. What is the difference between the highest and the lowest Expenditure(as % of GDP) in 1996?
Offer a very short reply. 5.81. What is the difference between the highest and the lowest Expenditure(as % of GDP) of 1997?
Your response must be concise. 6.36. What is the difference between the highest and the lowest Expenditure(as % of GDP) in 1998?
Offer a terse response. 7.06. 